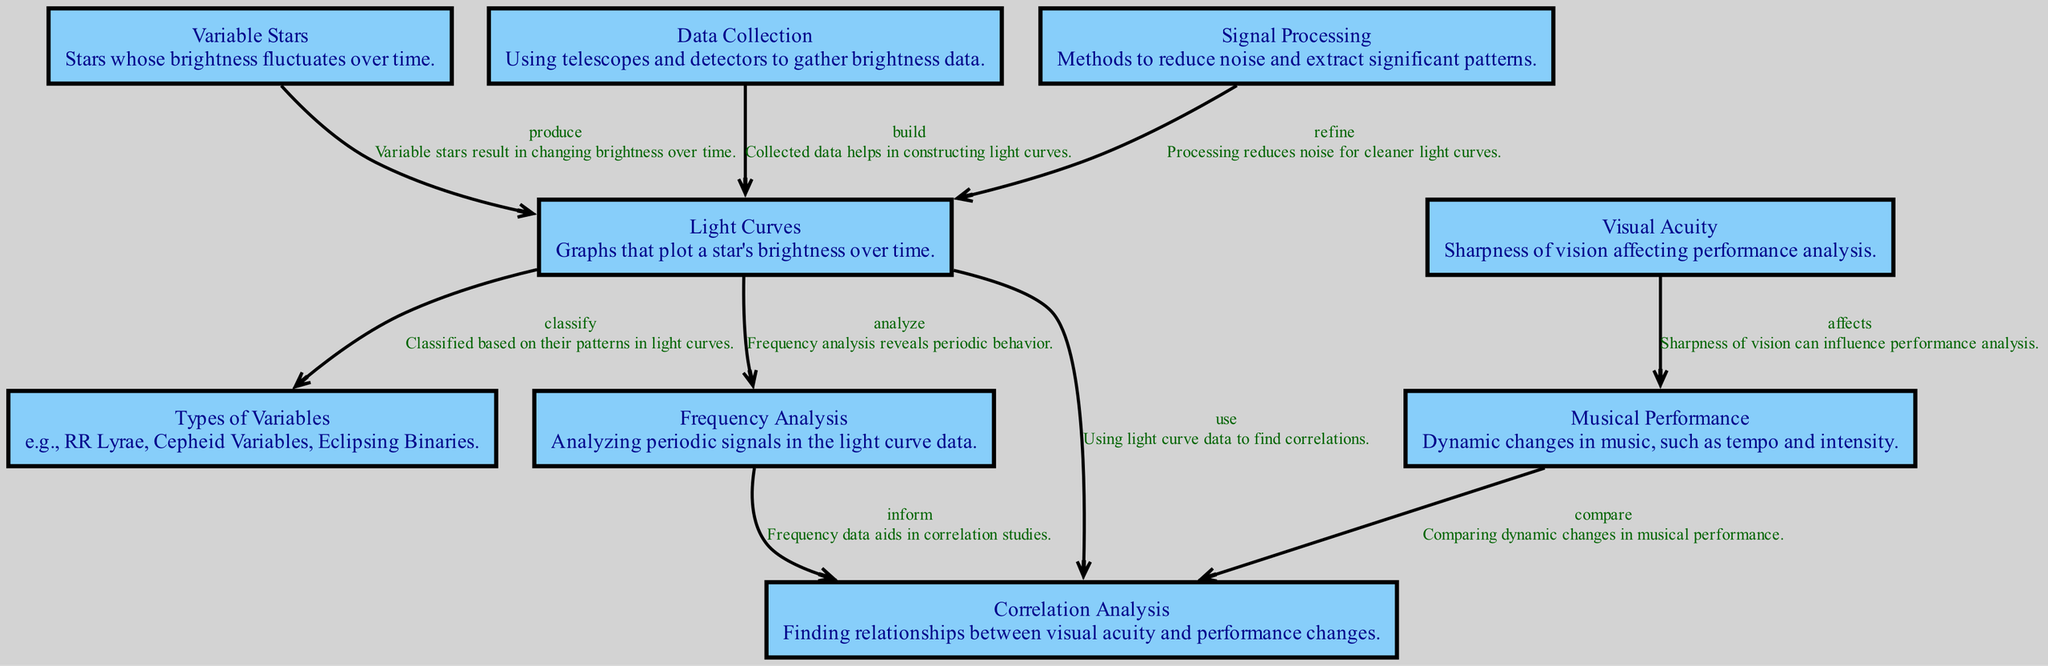What are variable stars? Variable stars are defined in the diagram as stars whose brightness fluctuates over time. This information is found in the description of the "Variable Stars" node.
Answer: Stars whose brightness fluctuates over time How many types of variables are listed in the diagram? The diagram shows a node labeled "Types of Variables," which indicates that there are different classifications, including examples like RR Lyrae and Cepheid Variables. The exact total isn't stated, but it suggests there are multiple types.
Answer: Multiple types What is the primary purpose of light curves? According to the diagram, light curves are graphs that plot a star's brightness over time, serving the purpose of visualizing changes in brightness.
Answer: Plot brightness over time What do signal processing methods do in the context of light curves? The "Signal Processing" node connects to "Light Curves," indicating that these methods refine the light curves by reducing noise and extracting significant patterns.
Answer: Reduce noise How does visual acuity affect musical performance? From the diagram's "Visual Acuity" node, it states this characteristic affects musical performance, implying that clarity of vision is relevant to how performance is analyzed.
Answer: Affects What relationship does frequency analysis have with correlation analysis? The diagram indicates that frequency analysis informs correlation analysis. This means that frequency data aids in finding relationships between visual acuity and musical performance dynamics.
Answer: Inform How many edges are in the diagram? By counting the connections (or edges) between the nodes in the diagram, we find there are eight described relationships linking various elements.
Answer: Eight What is used to build light curves? The "Data Collection" node specifies that collected data using telescopes and detectors is essential for constructing light curves.
Answer: Collected data Which process follows light curves after frequency analysis? The "Correlation Analysis" node directly follows from "Frequency Analysis" in the diagram, indicating it comes next in the analysis workflow.
Answer: Correlation Analysis 